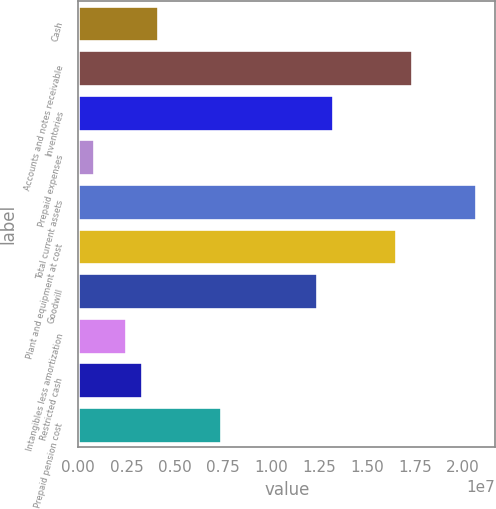Convert chart. <chart><loc_0><loc_0><loc_500><loc_500><bar_chart><fcel>Cash<fcel>Accounts and notes receivable<fcel>Inventories<fcel>Prepaid expenses<fcel>Total current assets<fcel>Plant and equipment at cost<fcel>Goodwill<fcel>Intangibles less amortization<fcel>Restricted cash<fcel>Prepaid pension cost<nl><fcel>4.14079e+06<fcel>1.73475e+07<fcel>1.32204e+07<fcel>839100<fcel>2.06492e+07<fcel>1.65221e+07<fcel>1.2395e+07<fcel>2.48994e+06<fcel>3.31537e+06<fcel>7.44248e+06<nl></chart> 